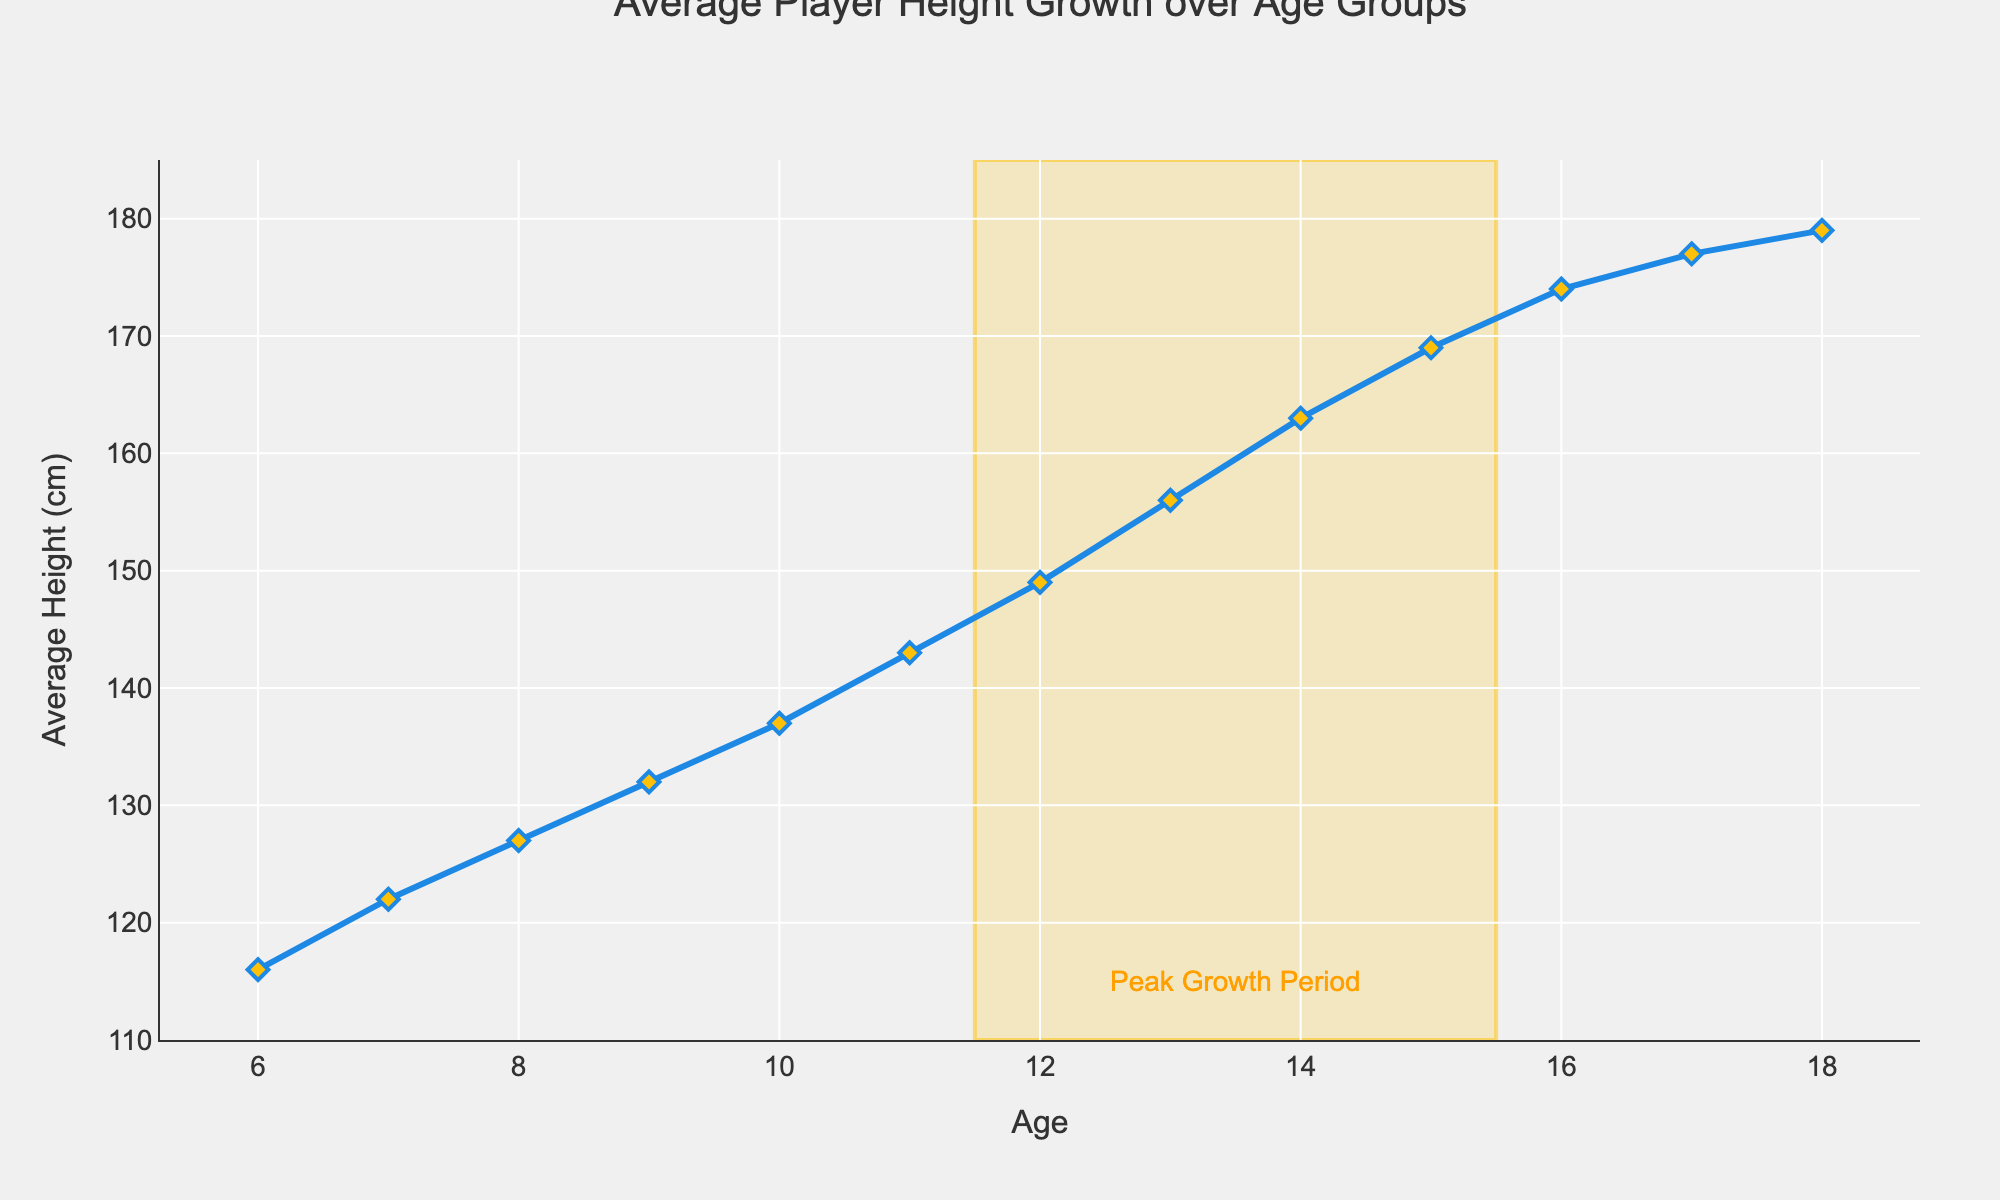What's the average height of players aged 10 and 12 combined? First, identify the heights at ages 10 and 12, which are 137 cm and 149 cm respectively. Add them together (137 + 149 = 286) and then divide by 2 to get the average.
Answer: 143 cm Between which ages does the most significant growth period occur? The most significant growth period is highlighted by the rectangle in the chart, which spans from ages 11.5 to 15.5.
Answer: 11.5 - 15.5 years What is the difference in average height between players aged 14 and 18? The height at age 14 is 163 cm, and at age 18 is 179 cm. Subtract the height at age 14 from the height at age 18 (179 - 163).
Answer: 16 cm Is the average height increase per year greater before or after age 13? Before age 13, the heights are: 116, 122, 127, 132, 137, 143, 149. After age 13, the heights are: 156, 163, 169, 174, 177, 179. Calculate incremental differences and average them for both periods. Before 13 the differences are (122-116, 127-122, 132-127, 137-132, 143-137, 149-143) which averages to 5.5 cm per year. After 13 the differences are (163-156, 169-163, 174-169, 177-174, 179-177) which averages to 4.6 cm per year. Average 5.5 cm before and 4.6 cm after.
Answer: 5.5 cm before age 13 At what age does the average height reach 150 cm? The height of 149 cm at age 12 and the next data point is 156 cm at age 13, so the average height reaches around 150 cm approximately at age 12.5.
Answer: 12.5 years 